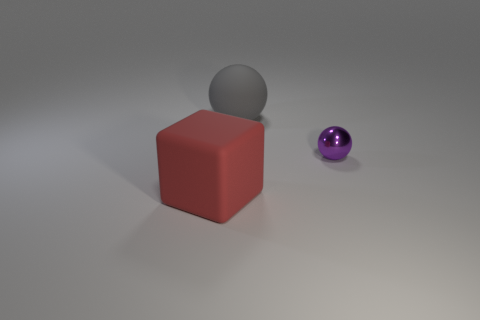Subtract all cyan cubes. Subtract all purple cylinders. How many cubes are left? 1 Add 2 tiny red rubber objects. How many objects exist? 5 Subtract all blocks. How many objects are left? 2 Add 3 large spheres. How many large spheres are left? 4 Add 1 gray spheres. How many gray spheres exist? 2 Subtract 0 green cubes. How many objects are left? 3 Subtract all large gray balls. Subtract all cubes. How many objects are left? 1 